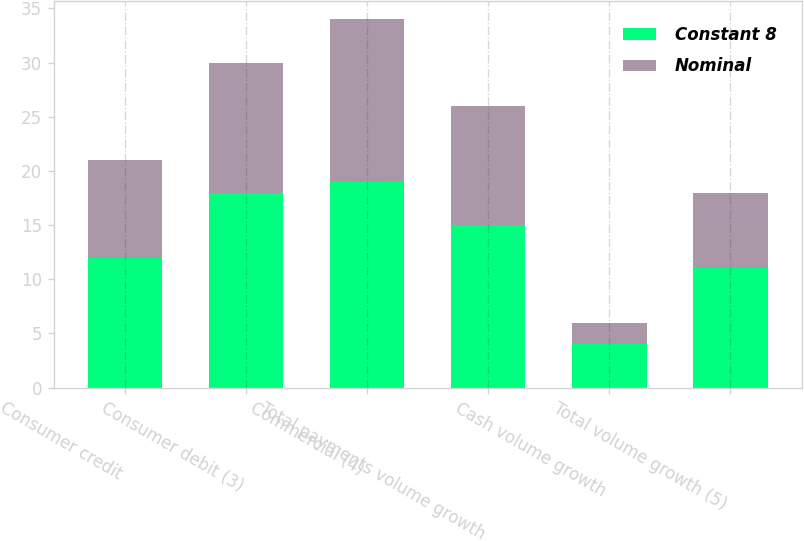<chart> <loc_0><loc_0><loc_500><loc_500><stacked_bar_chart><ecel><fcel>Consumer credit<fcel>Consumer debit (3)<fcel>Commercial (4)<fcel>Total payments volume growth<fcel>Cash volume growth<fcel>Total volume growth (5)<nl><fcel>Constant 8<fcel>12<fcel>18<fcel>19<fcel>15<fcel>4<fcel>11<nl><fcel>Nominal<fcel>9<fcel>12<fcel>15<fcel>11<fcel>2<fcel>7<nl></chart> 